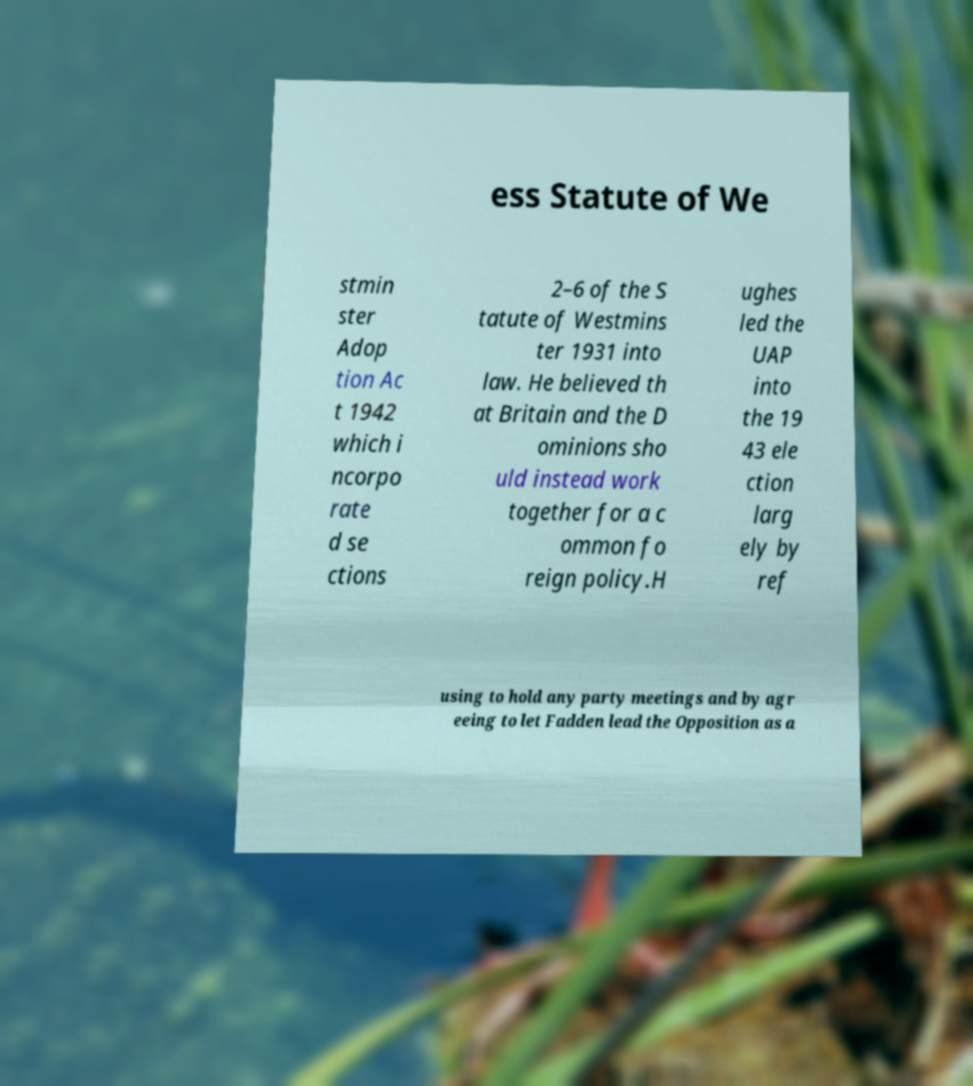Can you read and provide the text displayed in the image?This photo seems to have some interesting text. Can you extract and type it out for me? ess Statute of We stmin ster Adop tion Ac t 1942 which i ncorpo rate d se ctions 2–6 of the S tatute of Westmins ter 1931 into law. He believed th at Britain and the D ominions sho uld instead work together for a c ommon fo reign policy.H ughes led the UAP into the 19 43 ele ction larg ely by ref using to hold any party meetings and by agr eeing to let Fadden lead the Opposition as a 